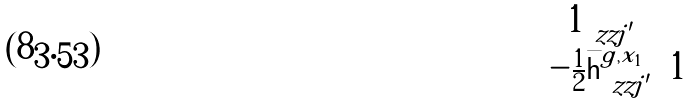<formula> <loc_0><loc_0><loc_500><loc_500>\begin{matrix} \mathbf 1 _ { \ z z j ^ { \prime } } & \\ - \frac { 1 } { 2 } \bar { \mathsf h } _ { \ z z j ^ { \prime } } ^ { g , x _ { 1 } } & 1 \end{matrix}</formula> 